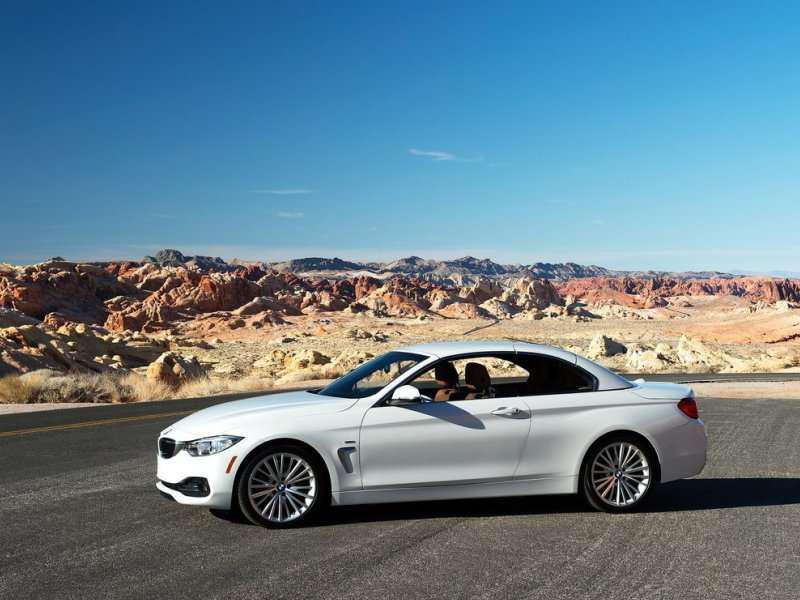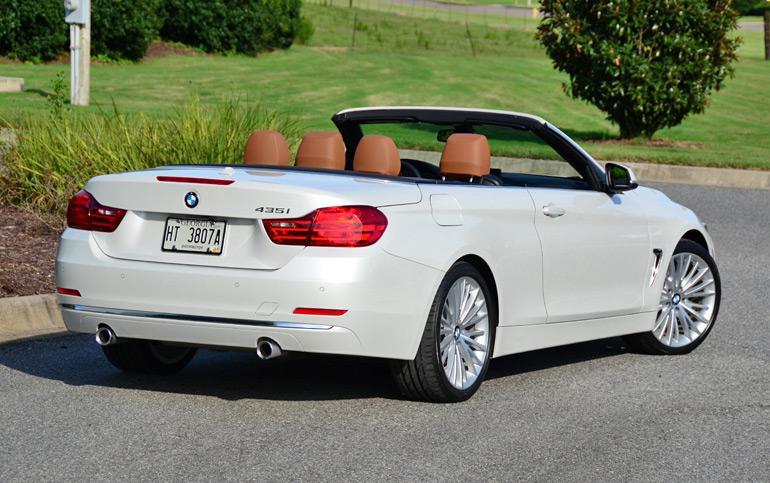The first image is the image on the left, the second image is the image on the right. Considering the images on both sides, is "Two sports cars with chrome wheels and dual exhaust are parked at an angle so that the rear license plate is visible." valid? Answer yes or no. No. The first image is the image on the left, the second image is the image on the right. Considering the images on both sides, is "An image shows a convertible with top down angled rightward, with tailights facing the camera." valid? Answer yes or no. Yes. 